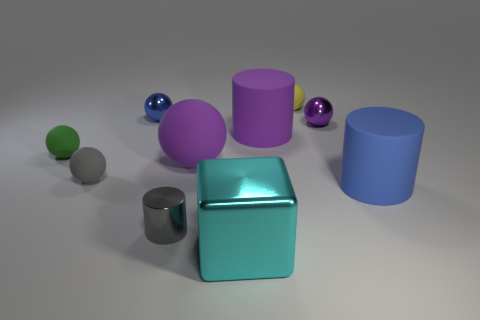Subtract all tiny metallic balls. How many balls are left? 4 Subtract all cyan blocks. How many purple spheres are left? 2 Subtract all purple spheres. How many spheres are left? 4 Subtract 1 cylinders. How many cylinders are left? 2 Subtract all cylinders. How many objects are left? 7 Subtract all red cylinders. Subtract all cyan cubes. How many cylinders are left? 3 Subtract all tiny red spheres. Subtract all large blue cylinders. How many objects are left? 9 Add 8 big blue matte cylinders. How many big blue matte cylinders are left? 9 Add 10 big brown shiny things. How many big brown shiny things exist? 10 Subtract 0 yellow cubes. How many objects are left? 10 